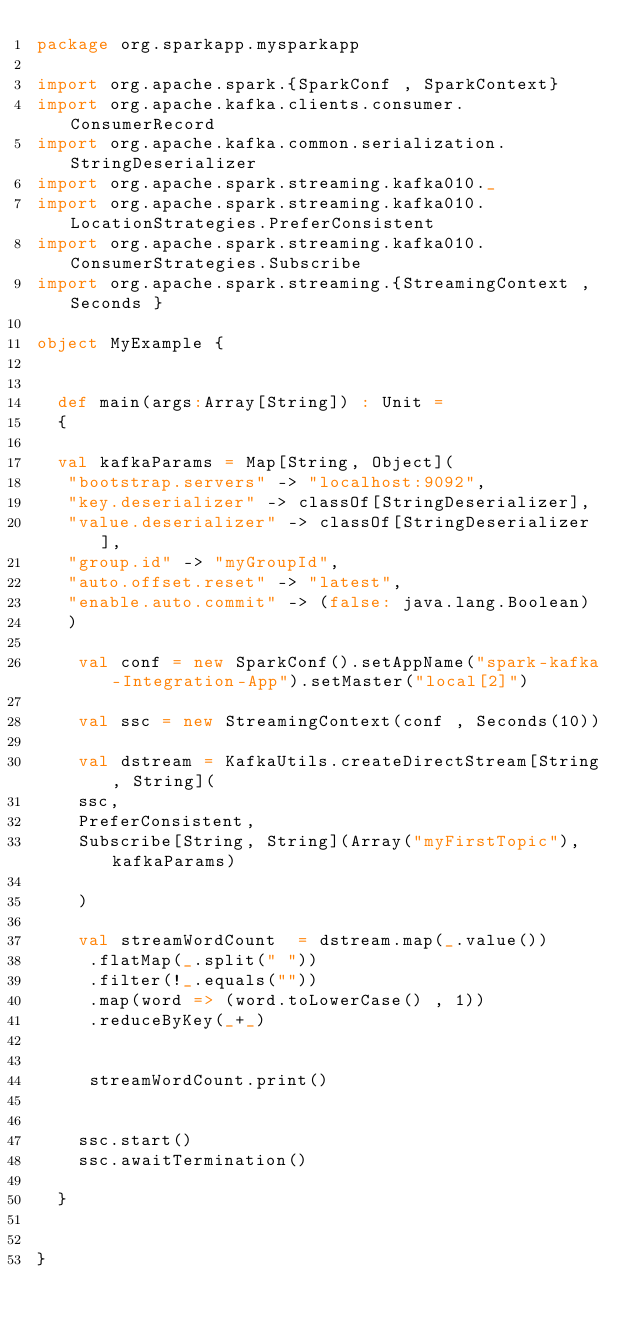<code> <loc_0><loc_0><loc_500><loc_500><_Scala_>package org.sparkapp.mysparkapp

import org.apache.spark.{SparkConf , SparkContext}
import org.apache.kafka.clients.consumer.ConsumerRecord
import org.apache.kafka.common.serialization.StringDeserializer
import org.apache.spark.streaming.kafka010._
import org.apache.spark.streaming.kafka010.LocationStrategies.PreferConsistent
import org.apache.spark.streaming.kafka010.ConsumerStrategies.Subscribe
import org.apache.spark.streaming.{StreamingContext , Seconds }

object MyExample {
  
  
  def main(args:Array[String]) : Unit = 
  {
    
  val kafkaParams = Map[String, Object](
   "bootstrap.servers" -> "localhost:9092",
   "key.deserializer" -> classOf[StringDeserializer],
   "value.deserializer" -> classOf[StringDeserializer],
   "group.id" -> "myGroupId",
   "auto.offset.reset" -> "latest",
   "enable.auto.commit" -> (false: java.lang.Boolean)
   )
   
    val conf = new SparkConf().setAppName("spark-kafka-Integration-App").setMaster("local[2]")
    
    val ssc = new StreamingContext(conf , Seconds(10))
    
    val dstream = KafkaUtils.createDirectStream[String, String](
    ssc,
    PreferConsistent,
    Subscribe[String, String](Array("myFirstTopic"), kafkaParams)
       
    )
    
    val streamWordCount  = dstream.map(_.value())
     .flatMap(_.split(" "))
     .filter(!_.equals(""))
     .map(word => (word.toLowerCase() , 1))
     .reduceByKey(_+_)
    
     
     streamWordCount.print()
    
     
    ssc.start()  
    ssc.awaitTermination()
    
  }
  
  
}
</code> 